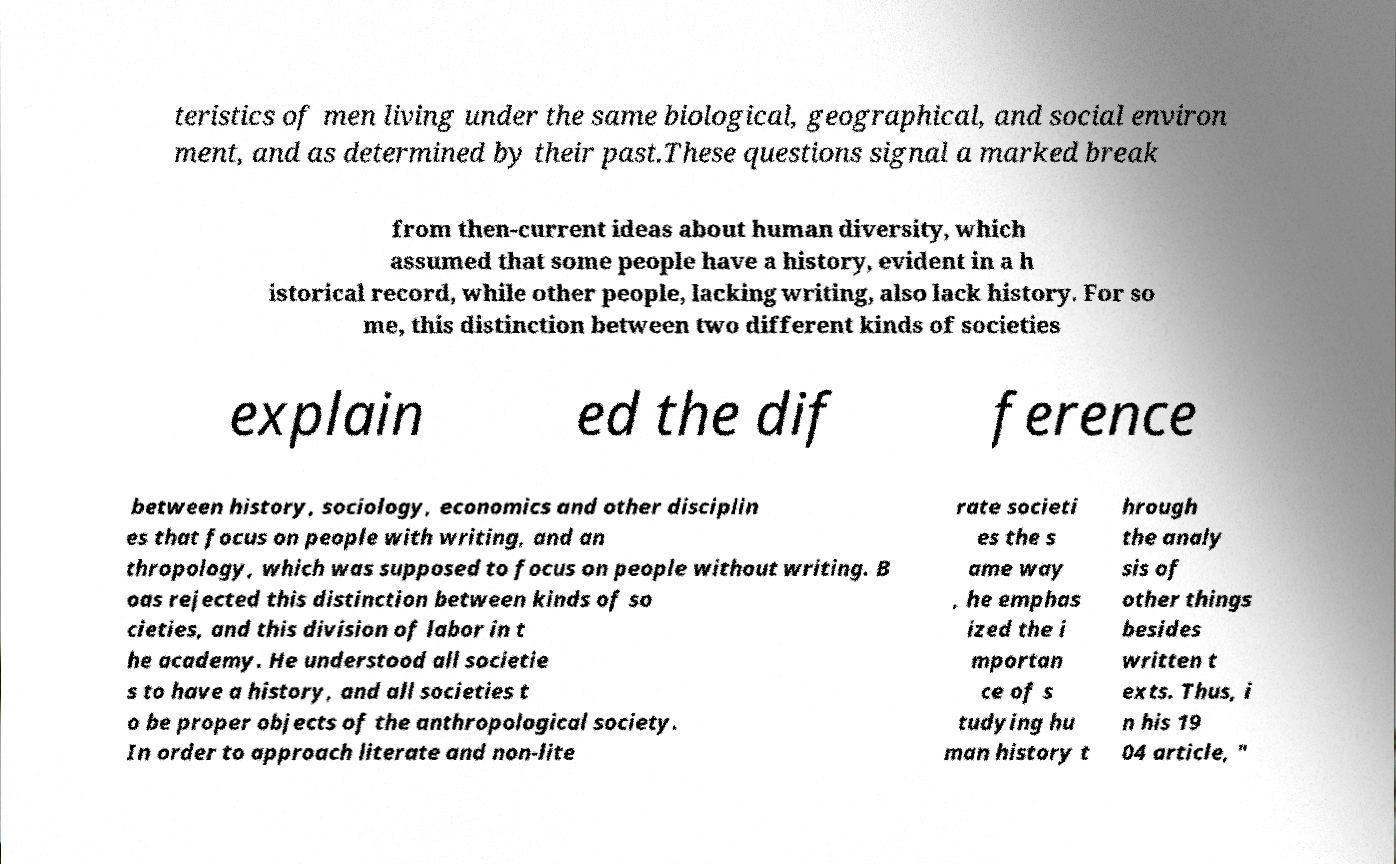For documentation purposes, I need the text within this image transcribed. Could you provide that? teristics of men living under the same biological, geographical, and social environ ment, and as determined by their past.These questions signal a marked break from then-current ideas about human diversity, which assumed that some people have a history, evident in a h istorical record, while other people, lacking writing, also lack history. For so me, this distinction between two different kinds of societies explain ed the dif ference between history, sociology, economics and other disciplin es that focus on people with writing, and an thropology, which was supposed to focus on people without writing. B oas rejected this distinction between kinds of so cieties, and this division of labor in t he academy. He understood all societie s to have a history, and all societies t o be proper objects of the anthropological society. In order to approach literate and non-lite rate societi es the s ame way , he emphas ized the i mportan ce of s tudying hu man history t hrough the analy sis of other things besides written t exts. Thus, i n his 19 04 article, " 